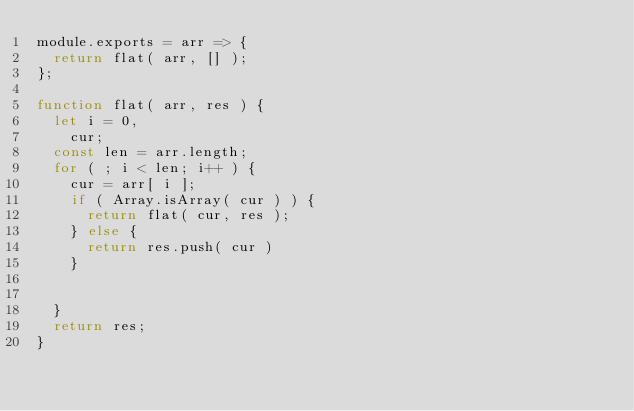Convert code to text. <code><loc_0><loc_0><loc_500><loc_500><_JavaScript_>module.exports = arr => {
  return flat( arr, [] );
};

function flat( arr, res ) {
  let i = 0,
    cur;
  const len = arr.length;
  for ( ; i < len; i++ ) {
    cur = arr[ i ];
    if ( Array.isArray( cur ) ) {
      return flat( cur, res );
    } else {
      return res.push( cur )
    }


  }
  return res;
}
</code> 